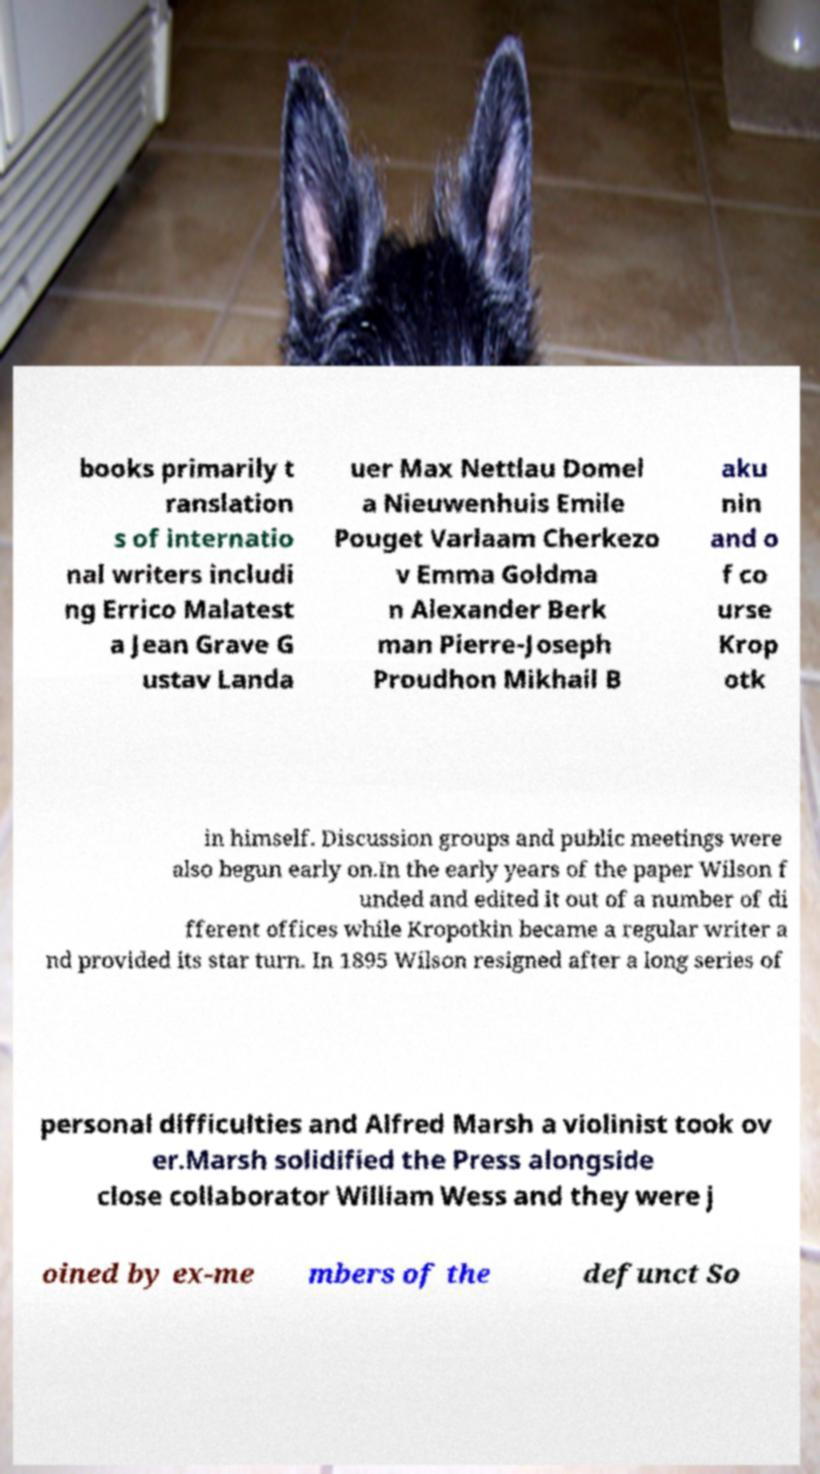What messages or text are displayed in this image? I need them in a readable, typed format. books primarily t ranslation s of internatio nal writers includi ng Errico Malatest a Jean Grave G ustav Landa uer Max Nettlau Domel a Nieuwenhuis Emile Pouget Varlaam Cherkezo v Emma Goldma n Alexander Berk man Pierre-Joseph Proudhon Mikhail B aku nin and o f co urse Krop otk in himself. Discussion groups and public meetings were also begun early on.In the early years of the paper Wilson f unded and edited it out of a number of di fferent offices while Kropotkin became a regular writer a nd provided its star turn. In 1895 Wilson resigned after a long series of personal difficulties and Alfred Marsh a violinist took ov er.Marsh solidified the Press alongside close collaborator William Wess and they were j oined by ex-me mbers of the defunct So 